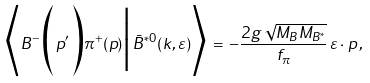<formula> <loc_0><loc_0><loc_500><loc_500>\Big \langle B ^ { - } \Big ( p ^ { \prime } \Big ) \pi ^ { + } ( p ) \Big | \bar { B } ^ { * 0 } ( k , \varepsilon ) \Big \rangle \, = \, - { \frac { 2 g \, \sqrt { M _ { B } M _ { B ^ { * } } } } { f _ { \pi } } } \, \varepsilon \cdot p \, ,</formula> 